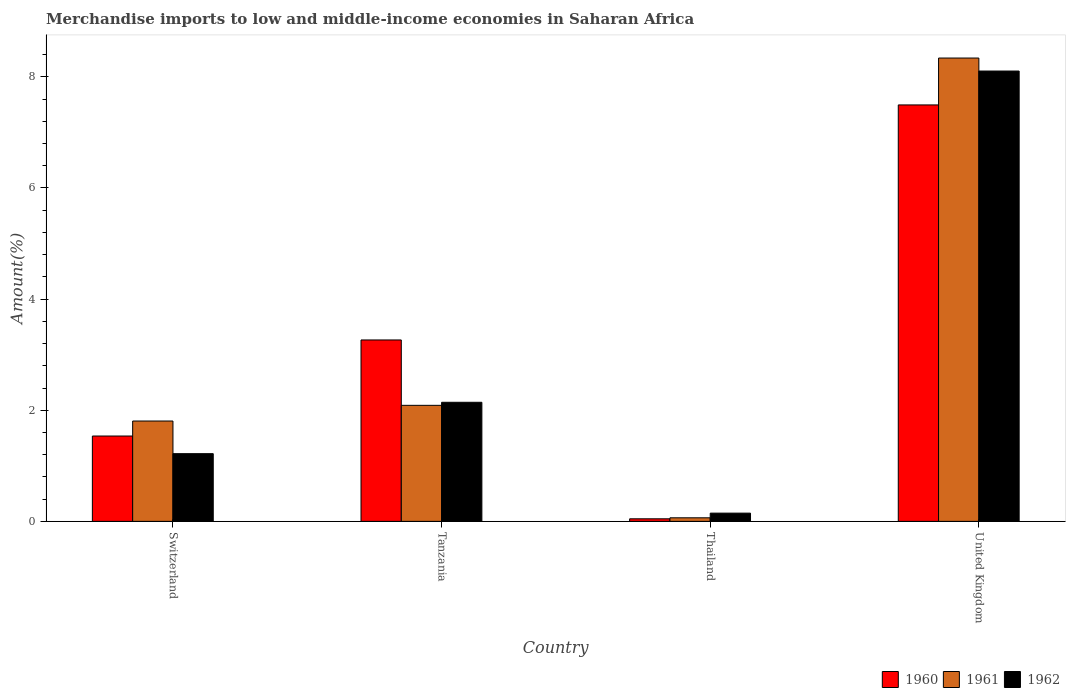How many groups of bars are there?
Give a very brief answer. 4. Are the number of bars on each tick of the X-axis equal?
Give a very brief answer. Yes. How many bars are there on the 4th tick from the left?
Keep it short and to the point. 3. What is the label of the 2nd group of bars from the left?
Give a very brief answer. Tanzania. In how many cases, is the number of bars for a given country not equal to the number of legend labels?
Make the answer very short. 0. What is the percentage of amount earned from merchandise imports in 1960 in United Kingdom?
Offer a terse response. 7.49. Across all countries, what is the maximum percentage of amount earned from merchandise imports in 1961?
Make the answer very short. 8.34. Across all countries, what is the minimum percentage of amount earned from merchandise imports in 1961?
Your response must be concise. 0.06. In which country was the percentage of amount earned from merchandise imports in 1960 maximum?
Your answer should be compact. United Kingdom. In which country was the percentage of amount earned from merchandise imports in 1961 minimum?
Provide a succinct answer. Thailand. What is the total percentage of amount earned from merchandise imports in 1961 in the graph?
Your answer should be very brief. 12.3. What is the difference between the percentage of amount earned from merchandise imports in 1961 in Tanzania and that in Thailand?
Offer a terse response. 2.02. What is the difference between the percentage of amount earned from merchandise imports in 1961 in United Kingdom and the percentage of amount earned from merchandise imports in 1960 in Thailand?
Keep it short and to the point. 8.29. What is the average percentage of amount earned from merchandise imports in 1960 per country?
Keep it short and to the point. 3.09. What is the difference between the percentage of amount earned from merchandise imports of/in 1961 and percentage of amount earned from merchandise imports of/in 1962 in Switzerland?
Give a very brief answer. 0.59. In how many countries, is the percentage of amount earned from merchandise imports in 1962 greater than 0.8 %?
Make the answer very short. 3. What is the ratio of the percentage of amount earned from merchandise imports in 1960 in Switzerland to that in United Kingdom?
Your response must be concise. 0.2. Is the difference between the percentage of amount earned from merchandise imports in 1961 in Switzerland and Tanzania greater than the difference between the percentage of amount earned from merchandise imports in 1962 in Switzerland and Tanzania?
Make the answer very short. Yes. What is the difference between the highest and the second highest percentage of amount earned from merchandise imports in 1961?
Provide a short and direct response. 6.53. What is the difference between the highest and the lowest percentage of amount earned from merchandise imports in 1962?
Make the answer very short. 7.96. Is the sum of the percentage of amount earned from merchandise imports in 1961 in Tanzania and United Kingdom greater than the maximum percentage of amount earned from merchandise imports in 1960 across all countries?
Your answer should be very brief. Yes. Is it the case that in every country, the sum of the percentage of amount earned from merchandise imports in 1960 and percentage of amount earned from merchandise imports in 1962 is greater than the percentage of amount earned from merchandise imports in 1961?
Make the answer very short. Yes. Are all the bars in the graph horizontal?
Give a very brief answer. No. How are the legend labels stacked?
Provide a succinct answer. Horizontal. What is the title of the graph?
Your answer should be compact. Merchandise imports to low and middle-income economies in Saharan Africa. What is the label or title of the X-axis?
Provide a short and direct response. Country. What is the label or title of the Y-axis?
Your response must be concise. Amount(%). What is the Amount(%) of 1960 in Switzerland?
Make the answer very short. 1.54. What is the Amount(%) in 1961 in Switzerland?
Provide a short and direct response. 1.81. What is the Amount(%) in 1962 in Switzerland?
Provide a succinct answer. 1.22. What is the Amount(%) of 1960 in Tanzania?
Keep it short and to the point. 3.26. What is the Amount(%) of 1961 in Tanzania?
Ensure brevity in your answer.  2.09. What is the Amount(%) in 1962 in Tanzania?
Offer a very short reply. 2.14. What is the Amount(%) in 1960 in Thailand?
Provide a short and direct response. 0.05. What is the Amount(%) of 1961 in Thailand?
Your response must be concise. 0.06. What is the Amount(%) of 1962 in Thailand?
Your answer should be very brief. 0.15. What is the Amount(%) of 1960 in United Kingdom?
Keep it short and to the point. 7.49. What is the Amount(%) in 1961 in United Kingdom?
Provide a succinct answer. 8.34. What is the Amount(%) of 1962 in United Kingdom?
Offer a very short reply. 8.1. Across all countries, what is the maximum Amount(%) of 1960?
Your answer should be very brief. 7.49. Across all countries, what is the maximum Amount(%) in 1961?
Your response must be concise. 8.34. Across all countries, what is the maximum Amount(%) of 1962?
Provide a succinct answer. 8.1. Across all countries, what is the minimum Amount(%) of 1960?
Ensure brevity in your answer.  0.05. Across all countries, what is the minimum Amount(%) in 1961?
Keep it short and to the point. 0.06. Across all countries, what is the minimum Amount(%) of 1962?
Make the answer very short. 0.15. What is the total Amount(%) of 1960 in the graph?
Offer a very short reply. 12.34. What is the total Amount(%) of 1961 in the graph?
Provide a succinct answer. 12.3. What is the total Amount(%) of 1962 in the graph?
Your answer should be compact. 11.61. What is the difference between the Amount(%) of 1960 in Switzerland and that in Tanzania?
Offer a very short reply. -1.73. What is the difference between the Amount(%) of 1961 in Switzerland and that in Tanzania?
Give a very brief answer. -0.28. What is the difference between the Amount(%) in 1962 in Switzerland and that in Tanzania?
Your answer should be very brief. -0.92. What is the difference between the Amount(%) of 1960 in Switzerland and that in Thailand?
Offer a terse response. 1.49. What is the difference between the Amount(%) of 1961 in Switzerland and that in Thailand?
Provide a short and direct response. 1.74. What is the difference between the Amount(%) in 1962 in Switzerland and that in Thailand?
Offer a very short reply. 1.07. What is the difference between the Amount(%) of 1960 in Switzerland and that in United Kingdom?
Your answer should be compact. -5.96. What is the difference between the Amount(%) in 1961 in Switzerland and that in United Kingdom?
Keep it short and to the point. -6.53. What is the difference between the Amount(%) of 1962 in Switzerland and that in United Kingdom?
Your answer should be very brief. -6.89. What is the difference between the Amount(%) of 1960 in Tanzania and that in Thailand?
Your answer should be very brief. 3.22. What is the difference between the Amount(%) of 1961 in Tanzania and that in Thailand?
Your answer should be very brief. 2.02. What is the difference between the Amount(%) of 1962 in Tanzania and that in Thailand?
Your response must be concise. 1.99. What is the difference between the Amount(%) in 1960 in Tanzania and that in United Kingdom?
Give a very brief answer. -4.23. What is the difference between the Amount(%) of 1961 in Tanzania and that in United Kingdom?
Ensure brevity in your answer.  -6.25. What is the difference between the Amount(%) of 1962 in Tanzania and that in United Kingdom?
Give a very brief answer. -5.96. What is the difference between the Amount(%) of 1960 in Thailand and that in United Kingdom?
Give a very brief answer. -7.45. What is the difference between the Amount(%) in 1961 in Thailand and that in United Kingdom?
Your response must be concise. -8.27. What is the difference between the Amount(%) in 1962 in Thailand and that in United Kingdom?
Your response must be concise. -7.96. What is the difference between the Amount(%) in 1960 in Switzerland and the Amount(%) in 1961 in Tanzania?
Offer a terse response. -0.55. What is the difference between the Amount(%) in 1960 in Switzerland and the Amount(%) in 1962 in Tanzania?
Your answer should be compact. -0.61. What is the difference between the Amount(%) in 1961 in Switzerland and the Amount(%) in 1962 in Tanzania?
Your answer should be very brief. -0.34. What is the difference between the Amount(%) of 1960 in Switzerland and the Amount(%) of 1961 in Thailand?
Make the answer very short. 1.47. What is the difference between the Amount(%) of 1960 in Switzerland and the Amount(%) of 1962 in Thailand?
Keep it short and to the point. 1.39. What is the difference between the Amount(%) of 1961 in Switzerland and the Amount(%) of 1962 in Thailand?
Your answer should be very brief. 1.66. What is the difference between the Amount(%) of 1960 in Switzerland and the Amount(%) of 1961 in United Kingdom?
Give a very brief answer. -6.8. What is the difference between the Amount(%) in 1960 in Switzerland and the Amount(%) in 1962 in United Kingdom?
Provide a succinct answer. -6.57. What is the difference between the Amount(%) in 1961 in Switzerland and the Amount(%) in 1962 in United Kingdom?
Offer a terse response. -6.3. What is the difference between the Amount(%) of 1960 in Tanzania and the Amount(%) of 1961 in Thailand?
Keep it short and to the point. 3.2. What is the difference between the Amount(%) of 1960 in Tanzania and the Amount(%) of 1962 in Thailand?
Your answer should be very brief. 3.12. What is the difference between the Amount(%) of 1961 in Tanzania and the Amount(%) of 1962 in Thailand?
Make the answer very short. 1.94. What is the difference between the Amount(%) of 1960 in Tanzania and the Amount(%) of 1961 in United Kingdom?
Give a very brief answer. -5.07. What is the difference between the Amount(%) in 1960 in Tanzania and the Amount(%) in 1962 in United Kingdom?
Your response must be concise. -4.84. What is the difference between the Amount(%) of 1961 in Tanzania and the Amount(%) of 1962 in United Kingdom?
Your answer should be very brief. -6.02. What is the difference between the Amount(%) in 1960 in Thailand and the Amount(%) in 1961 in United Kingdom?
Provide a short and direct response. -8.29. What is the difference between the Amount(%) of 1960 in Thailand and the Amount(%) of 1962 in United Kingdom?
Offer a very short reply. -8.06. What is the difference between the Amount(%) in 1961 in Thailand and the Amount(%) in 1962 in United Kingdom?
Give a very brief answer. -8.04. What is the average Amount(%) of 1960 per country?
Ensure brevity in your answer.  3.09. What is the average Amount(%) of 1961 per country?
Make the answer very short. 3.07. What is the average Amount(%) in 1962 per country?
Give a very brief answer. 2.9. What is the difference between the Amount(%) in 1960 and Amount(%) in 1961 in Switzerland?
Your answer should be compact. -0.27. What is the difference between the Amount(%) of 1960 and Amount(%) of 1962 in Switzerland?
Your response must be concise. 0.32. What is the difference between the Amount(%) in 1961 and Amount(%) in 1962 in Switzerland?
Offer a very short reply. 0.59. What is the difference between the Amount(%) in 1960 and Amount(%) in 1961 in Tanzania?
Offer a very short reply. 1.18. What is the difference between the Amount(%) of 1960 and Amount(%) of 1962 in Tanzania?
Provide a succinct answer. 1.12. What is the difference between the Amount(%) in 1961 and Amount(%) in 1962 in Tanzania?
Give a very brief answer. -0.05. What is the difference between the Amount(%) in 1960 and Amount(%) in 1961 in Thailand?
Your answer should be very brief. -0.02. What is the difference between the Amount(%) of 1960 and Amount(%) of 1962 in Thailand?
Keep it short and to the point. -0.1. What is the difference between the Amount(%) of 1961 and Amount(%) of 1962 in Thailand?
Your answer should be very brief. -0.08. What is the difference between the Amount(%) in 1960 and Amount(%) in 1961 in United Kingdom?
Your response must be concise. -0.84. What is the difference between the Amount(%) of 1960 and Amount(%) of 1962 in United Kingdom?
Offer a terse response. -0.61. What is the difference between the Amount(%) of 1961 and Amount(%) of 1962 in United Kingdom?
Provide a short and direct response. 0.23. What is the ratio of the Amount(%) in 1960 in Switzerland to that in Tanzania?
Make the answer very short. 0.47. What is the ratio of the Amount(%) of 1961 in Switzerland to that in Tanzania?
Your answer should be compact. 0.86. What is the ratio of the Amount(%) in 1962 in Switzerland to that in Tanzania?
Your response must be concise. 0.57. What is the ratio of the Amount(%) in 1960 in Switzerland to that in Thailand?
Your answer should be very brief. 33.33. What is the ratio of the Amount(%) in 1961 in Switzerland to that in Thailand?
Provide a short and direct response. 28.2. What is the ratio of the Amount(%) in 1962 in Switzerland to that in Thailand?
Your response must be concise. 8.23. What is the ratio of the Amount(%) of 1960 in Switzerland to that in United Kingdom?
Your answer should be very brief. 0.2. What is the ratio of the Amount(%) of 1961 in Switzerland to that in United Kingdom?
Provide a succinct answer. 0.22. What is the ratio of the Amount(%) of 1962 in Switzerland to that in United Kingdom?
Ensure brevity in your answer.  0.15. What is the ratio of the Amount(%) in 1960 in Tanzania to that in Thailand?
Give a very brief answer. 70.85. What is the ratio of the Amount(%) of 1961 in Tanzania to that in Thailand?
Offer a very short reply. 32.6. What is the ratio of the Amount(%) of 1962 in Tanzania to that in Thailand?
Your answer should be compact. 14.47. What is the ratio of the Amount(%) of 1960 in Tanzania to that in United Kingdom?
Offer a very short reply. 0.44. What is the ratio of the Amount(%) of 1961 in Tanzania to that in United Kingdom?
Ensure brevity in your answer.  0.25. What is the ratio of the Amount(%) of 1962 in Tanzania to that in United Kingdom?
Ensure brevity in your answer.  0.26. What is the ratio of the Amount(%) in 1960 in Thailand to that in United Kingdom?
Offer a terse response. 0.01. What is the ratio of the Amount(%) of 1961 in Thailand to that in United Kingdom?
Your response must be concise. 0.01. What is the ratio of the Amount(%) of 1962 in Thailand to that in United Kingdom?
Make the answer very short. 0.02. What is the difference between the highest and the second highest Amount(%) of 1960?
Your answer should be compact. 4.23. What is the difference between the highest and the second highest Amount(%) in 1961?
Ensure brevity in your answer.  6.25. What is the difference between the highest and the second highest Amount(%) in 1962?
Keep it short and to the point. 5.96. What is the difference between the highest and the lowest Amount(%) of 1960?
Give a very brief answer. 7.45. What is the difference between the highest and the lowest Amount(%) in 1961?
Make the answer very short. 8.27. What is the difference between the highest and the lowest Amount(%) of 1962?
Keep it short and to the point. 7.96. 